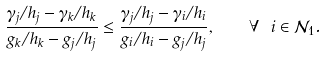<formula> <loc_0><loc_0><loc_500><loc_500>\frac { \gamma _ { j } / h _ { j } - \gamma _ { k } / h _ { k } } { g _ { k } / h _ { k } - g _ { j } / h _ { j } } \leq \frac { \gamma _ { j } / h _ { j } - \gamma _ { i } / h _ { i } } { g _ { i } / h _ { i } - g _ { j } / h _ { j } } , \quad \forall \ i \in \mathcal { N } _ { 1 } .</formula> 